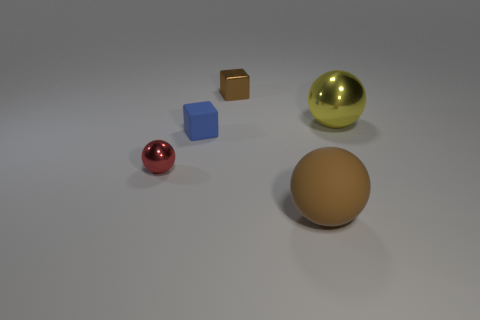What materials do the objects in the image seem to be made of? The objects appear to represent different materials: the small sphere looks metallic with a reflective pink surface, the large sphere seems to be a glossy yellow material, possibly metallic as well, the cube in the foreground appears matte and clay-like, and the cube in the back has a reflective bronze finish, suggesting it might be metal. 